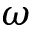<formula> <loc_0><loc_0><loc_500><loc_500>\omega</formula> 